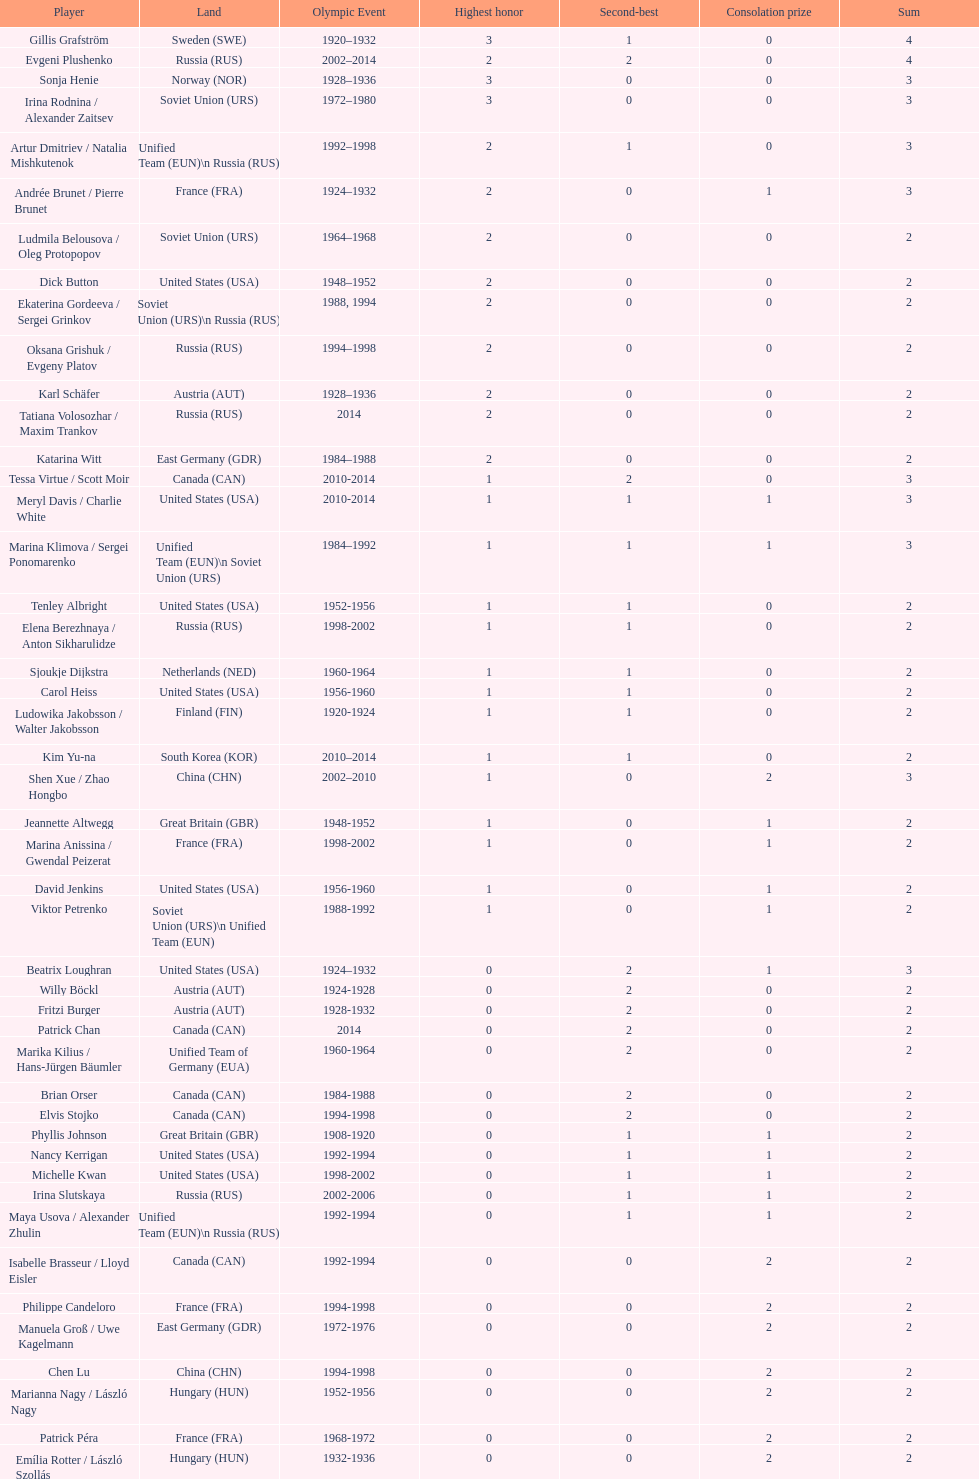How many medals have sweden and norway won combined? 7. 